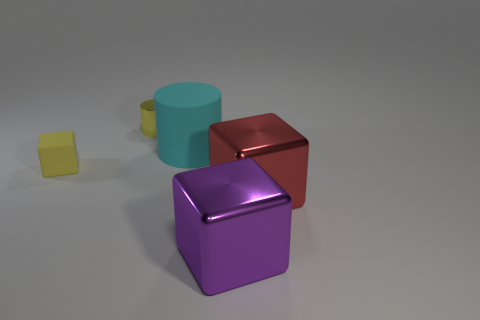What number of other things are there of the same shape as the big cyan object?
Provide a succinct answer. 1. What shape is the rubber object that is on the right side of the tiny shiny object?
Keep it short and to the point. Cylinder. Does the small cube have the same material as the big thing on the left side of the purple object?
Give a very brief answer. Yes. Do the big cyan rubber thing and the purple shiny thing have the same shape?
Make the answer very short. No. There is another object that is the same shape as the tiny metal object; what is it made of?
Offer a very short reply. Rubber. What color is the metallic object that is behind the big purple block and in front of the rubber cube?
Your answer should be very brief. Red. What is the color of the large rubber cylinder?
Give a very brief answer. Cyan. There is a object that is the same color as the metallic cylinder; what material is it?
Provide a short and direct response. Rubber. Is there a big yellow metal thing that has the same shape as the large red object?
Provide a succinct answer. No. What size is the metallic cylinder that is left of the red shiny cube?
Provide a succinct answer. Small. 